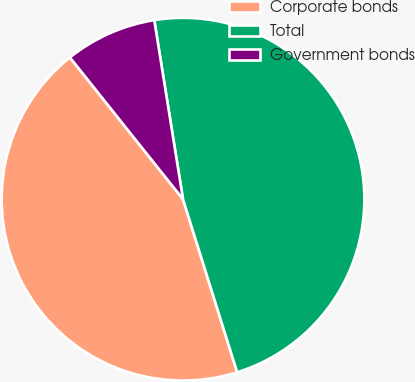<chart> <loc_0><loc_0><loc_500><loc_500><pie_chart><fcel>Corporate bonds<fcel>Total<fcel>Government bonds<nl><fcel>44.11%<fcel>47.7%<fcel>8.18%<nl></chart> 